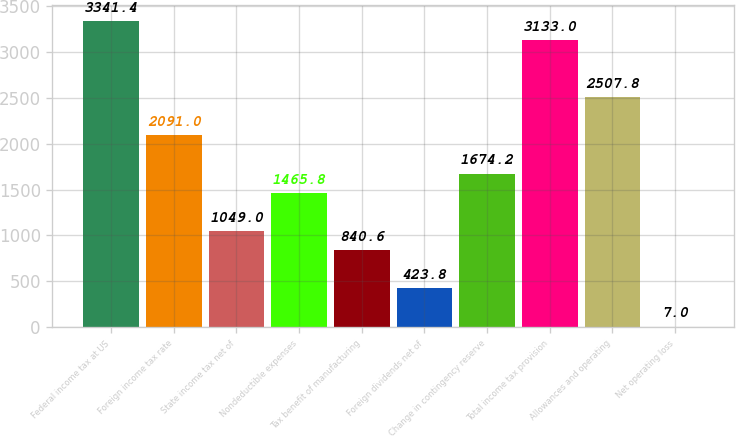Convert chart to OTSL. <chart><loc_0><loc_0><loc_500><loc_500><bar_chart><fcel>Federal income tax at US<fcel>Foreign income tax rate<fcel>State income tax net of<fcel>Nondeductible expenses<fcel>Tax benefit of manufacturing<fcel>Foreign dividends net of<fcel>Change in contingency reserve<fcel>Total income tax provision<fcel>Allowances and operating<fcel>Net operating loss<nl><fcel>3341.4<fcel>2091<fcel>1049<fcel>1465.8<fcel>840.6<fcel>423.8<fcel>1674.2<fcel>3133<fcel>2507.8<fcel>7<nl></chart> 